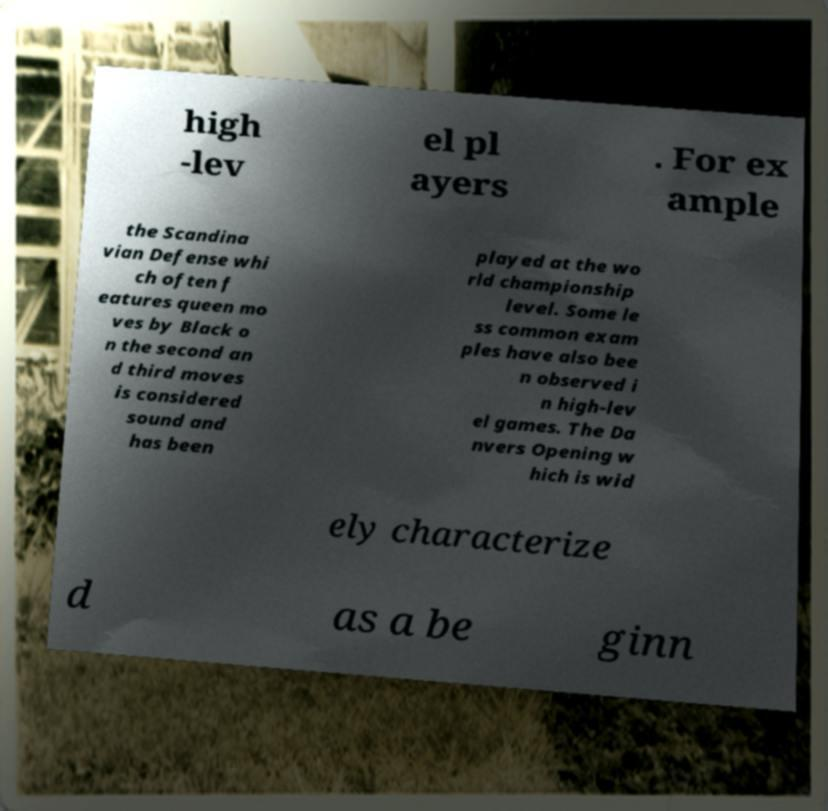Can you accurately transcribe the text from the provided image for me? high -lev el pl ayers . For ex ample the Scandina vian Defense whi ch often f eatures queen mo ves by Black o n the second an d third moves is considered sound and has been played at the wo rld championship level. Some le ss common exam ples have also bee n observed i n high-lev el games. The Da nvers Opening w hich is wid ely characterize d as a be ginn 